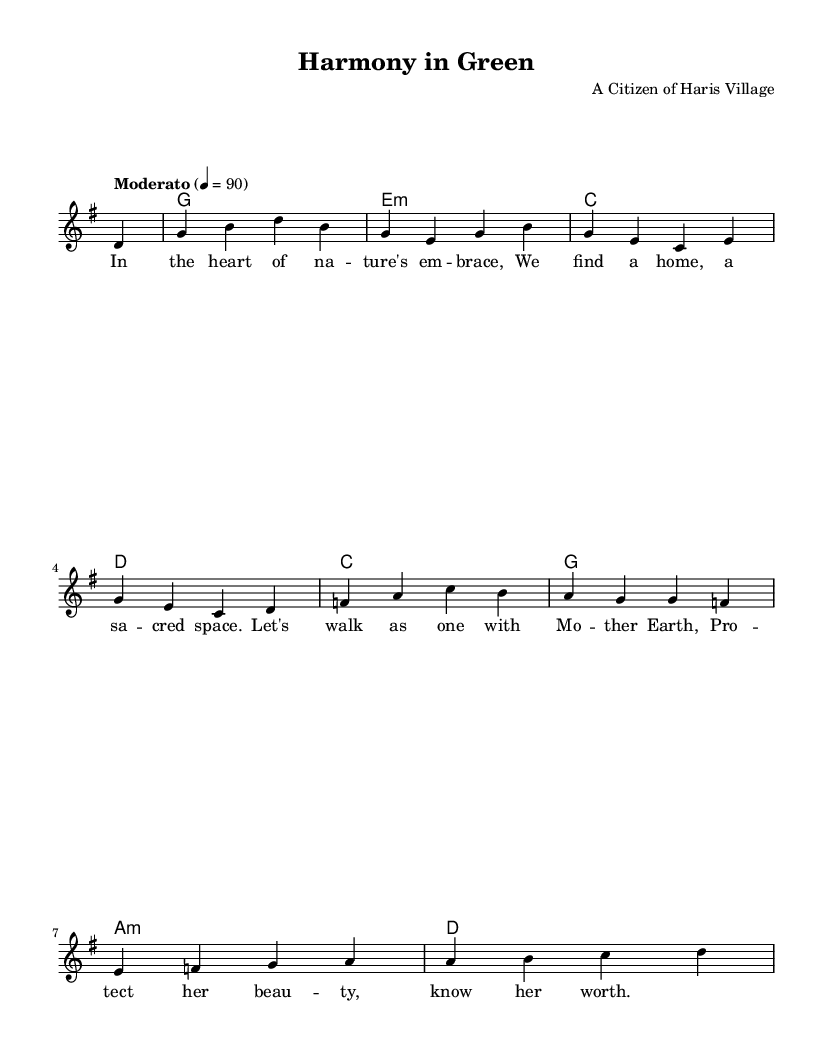What is the key signature of this music? The key signature is G major, which has one sharp (F#). This can be identified by looking at the key signature at the beginning of the staff.
Answer: G major What is the time signature of the piece? The time signature is 4/4, which indicates four beats per measure and a quarter note receives one beat. This can be seen next to the clef at the start of the music.
Answer: 4/4 What is the tempo marking? The tempo marking is Moderato, indicating a moderate speed for the piece. This is also noted at the beginning of the score above the staff.
Answer: Moderato How many measures are in the melody section? There are eight measures in the melody section, which can be counted by checking the bar lines in the staff.
Answer: 8 What are the first two chords played in the song? The first two chords are G and E minor. This can be determined by observing the chord symbols above the staff indicated at the start of the piece.
Answer: G, E minor What is the lyrical theme of the song? The lyrical theme emphasizes harmony with nature and environmental protection. This understanding comes from reading the lyrics provided beneath the melody notes.
Answer: Harmony with nature What type of song is "Harmony in Green"? "Harmony in Green" is an acoustic ballad promoting environmental conservation. This classification is evident from its lyrical content and gentle melodic structure.
Answer: Acoustic ballad 